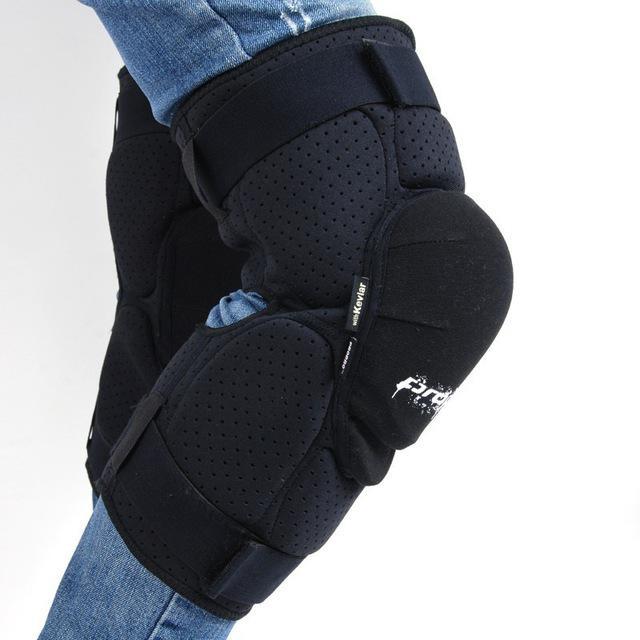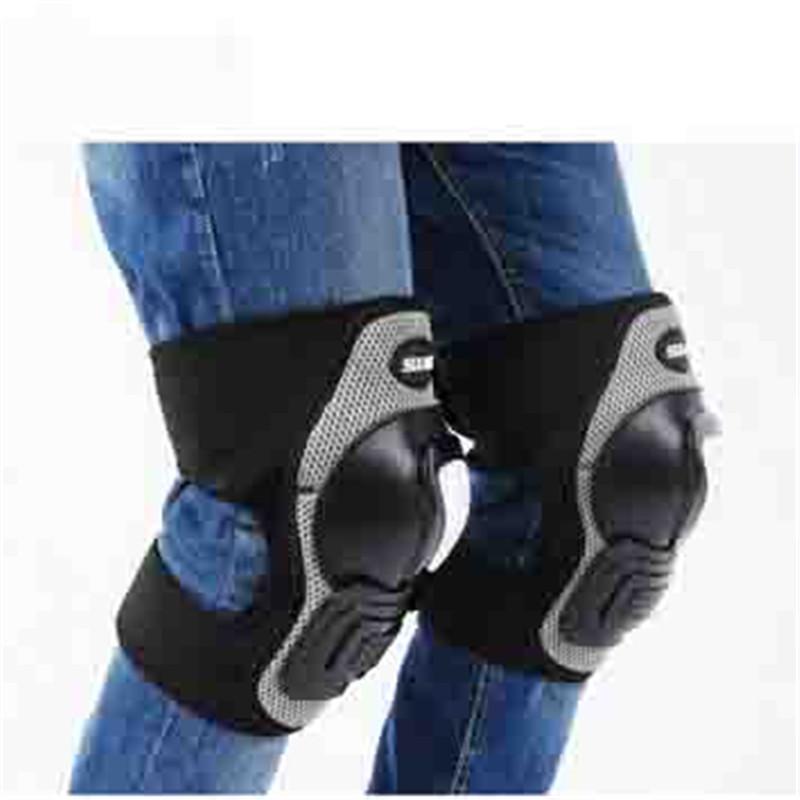The first image is the image on the left, the second image is the image on the right. For the images shown, is this caption "Both images show knee pads worn over denim jeans." true? Answer yes or no. Yes. The first image is the image on the left, the second image is the image on the right. Considering the images on both sides, is "Two sets of kneepads are shown as they fit on legs over jeans." valid? Answer yes or no. Yes. 